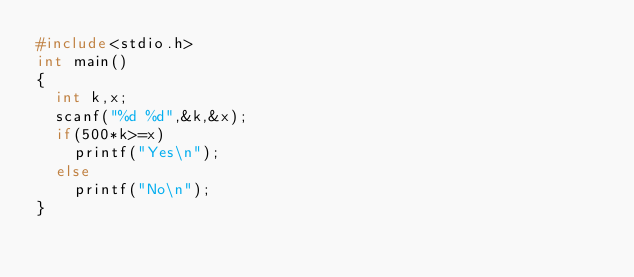<code> <loc_0><loc_0><loc_500><loc_500><_C_>#include<stdio.h>
int main()
{
	int k,x;
	scanf("%d %d",&k,&x);
	if(500*k>=x)
		printf("Yes\n");
	else
		printf("No\n");
}


</code> 